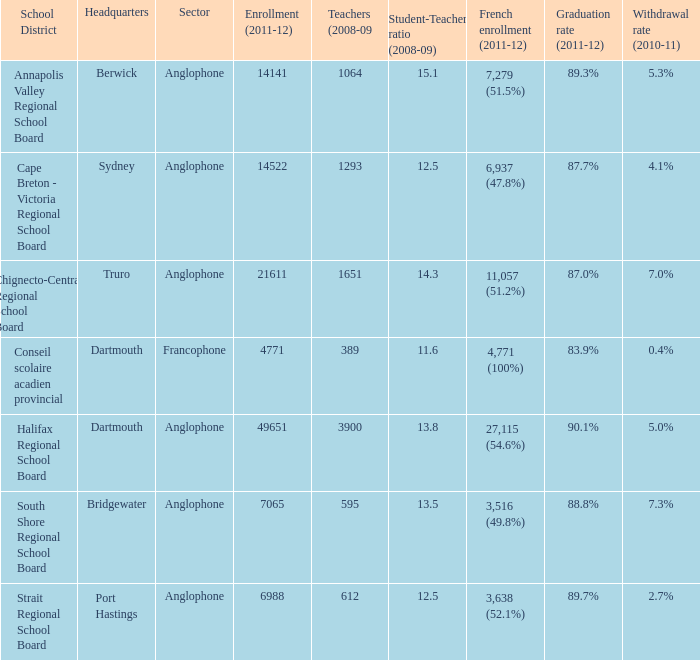What is the withdrawal rate for the school district with a graduation rate of 89.3%? 5.3%. Could you parse the entire table? {'header': ['School District', 'Headquarters', 'Sector', 'Enrollment (2011-12)', 'Teachers (2008-09', 'Student-Teacher ratio (2008-09)', 'French enrollment (2011-12)', 'Graduation rate (2011-12)', 'Withdrawal rate (2010-11)'], 'rows': [['Annapolis Valley Regional School Board', 'Berwick', 'Anglophone', '14141', '1064', '15.1', '7,279 (51.5%)', '89.3%', '5.3%'], ['Cape Breton - Victoria Regional School Board', 'Sydney', 'Anglophone', '14522', '1293', '12.5', '6,937 (47.8%)', '87.7%', '4.1%'], ['Chignecto-Central Regional School Board', 'Truro', 'Anglophone', '21611', '1651', '14.3', '11,057 (51.2%)', '87.0%', '7.0%'], ['Conseil scolaire acadien provincial', 'Dartmouth', 'Francophone', '4771', '389', '11.6', '4,771 (100%)', '83.9%', '0.4%'], ['Halifax Regional School Board', 'Dartmouth', 'Anglophone', '49651', '3900', '13.8', '27,115 (54.6%)', '90.1%', '5.0%'], ['South Shore Regional School Board', 'Bridgewater', 'Anglophone', '7065', '595', '13.5', '3,516 (49.8%)', '88.8%', '7.3%'], ['Strait Regional School Board', 'Port Hastings', 'Anglophone', '6988', '612', '12.5', '3,638 (52.1%)', '89.7%', '2.7%']]} 